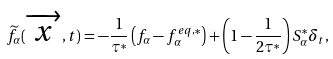Convert formula to latex. <formula><loc_0><loc_0><loc_500><loc_500>\widetilde { f } _ { \alpha } ( \overrightarrow { x } , t ) = - \frac { 1 } { \tau ^ { * } } \left ( f _ { \alpha } - f _ { \alpha } ^ { e q , * } \right ) + \left ( 1 - \frac { 1 } { 2 \tau ^ { * } } \right ) S _ { \alpha } ^ { * } \delta _ { t } ,</formula> 